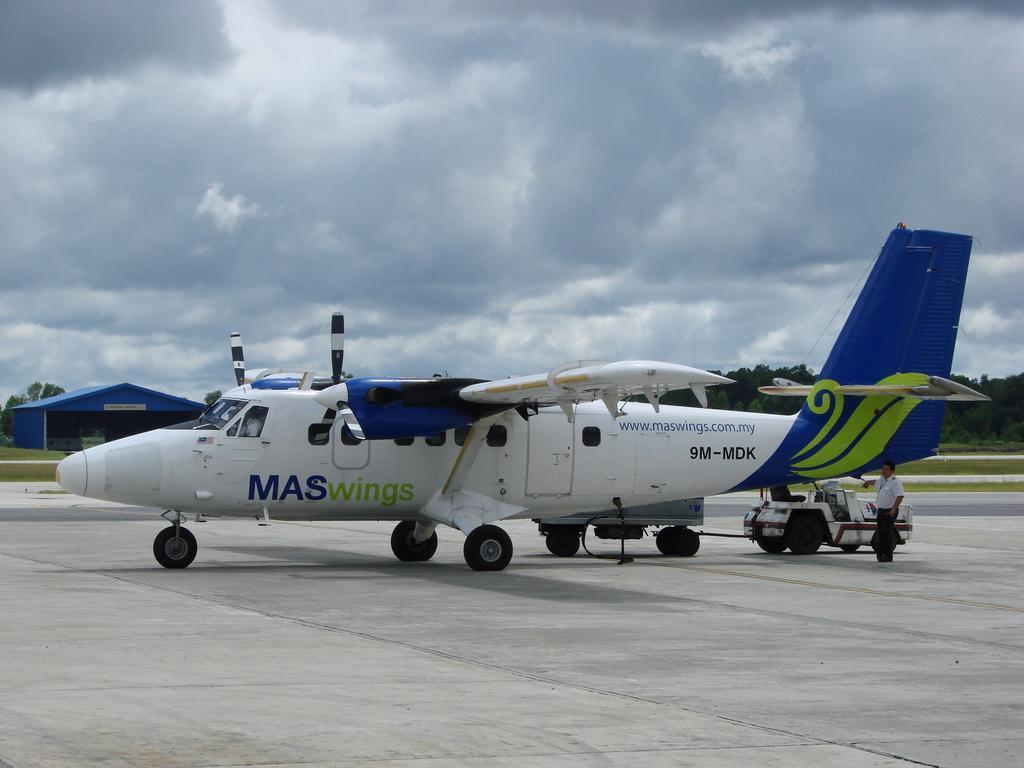In one or two sentences, can you explain what this image depicts? The picture consists of an airplane, a vehicle, a person on the runway. In the middle of the picture there are trees, grass, runway, a construction and other objects. At the top it is sky, sky is cloudy. 